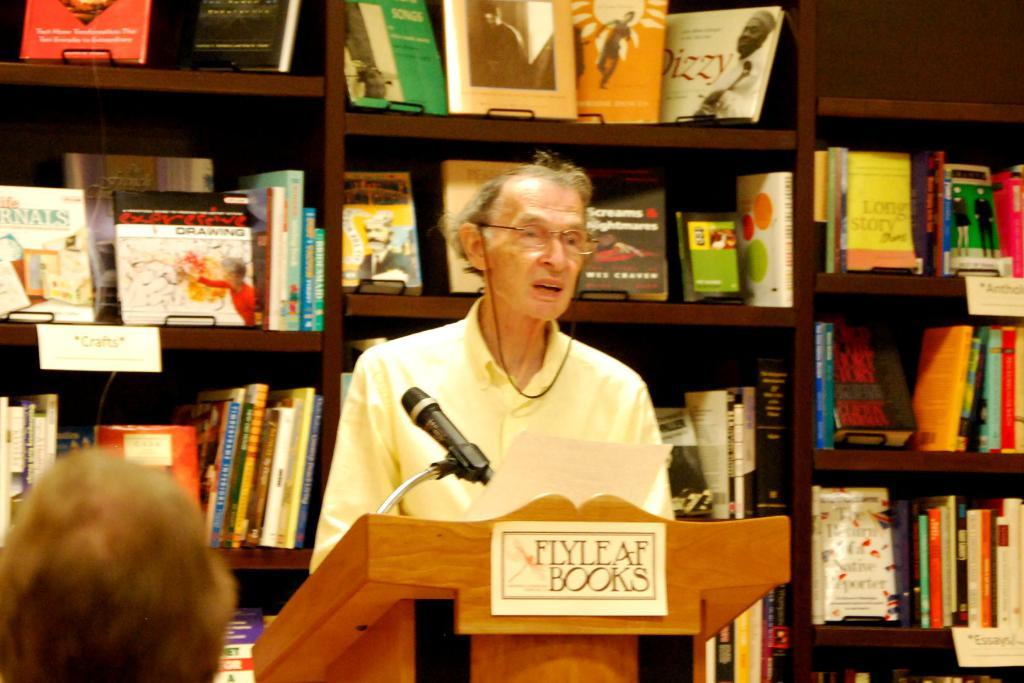Provide a one-sentence caption for the provided image. A speaker is at a podium with Flyleaf Books written on it. 